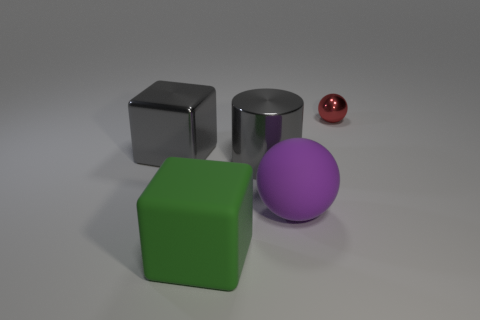Add 4 big red rubber cubes. How many objects exist? 9 Subtract all cylinders. How many objects are left? 4 Subtract 1 gray cylinders. How many objects are left? 4 Subtract all tiny blue rubber cylinders. Subtract all tiny red spheres. How many objects are left? 4 Add 1 red balls. How many red balls are left? 2 Add 3 tiny green matte cylinders. How many tiny green matte cylinders exist? 3 